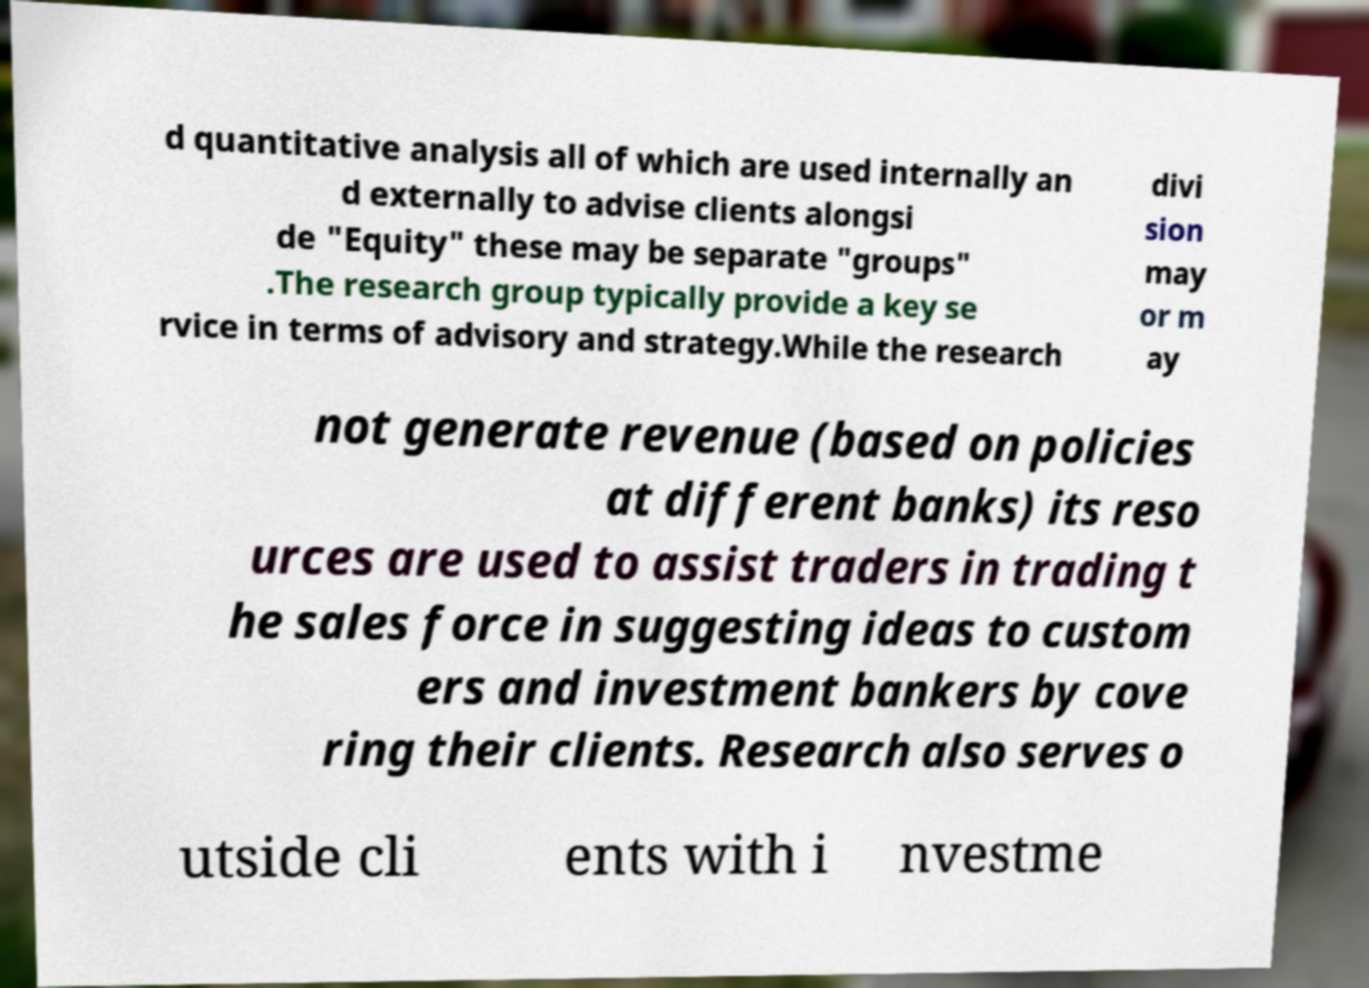Could you extract and type out the text from this image? d quantitative analysis all of which are used internally an d externally to advise clients alongsi de "Equity" these may be separate "groups" .The research group typically provide a key se rvice in terms of advisory and strategy.While the research divi sion may or m ay not generate revenue (based on policies at different banks) its reso urces are used to assist traders in trading t he sales force in suggesting ideas to custom ers and investment bankers by cove ring their clients. Research also serves o utside cli ents with i nvestme 